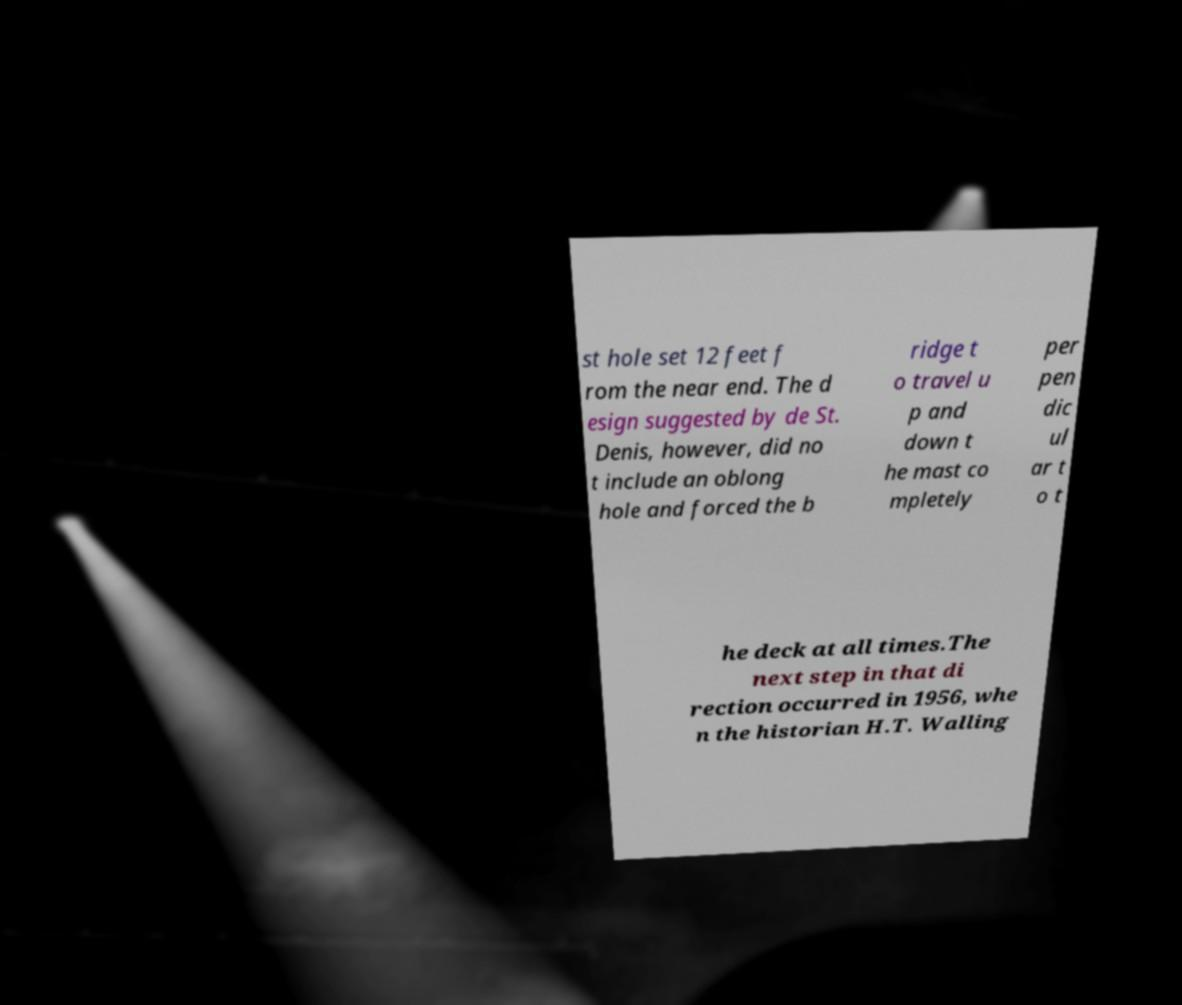Could you assist in decoding the text presented in this image and type it out clearly? st hole set 12 feet f rom the near end. The d esign suggested by de St. Denis, however, did no t include an oblong hole and forced the b ridge t o travel u p and down t he mast co mpletely per pen dic ul ar t o t he deck at all times.The next step in that di rection occurred in 1956, whe n the historian H.T. Walling 